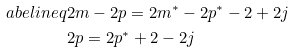Convert formula to latex. <formula><loc_0><loc_0><loc_500><loc_500>\L a b e l { i n e q } & 2 m - 2 p = 2 m ^ { * } - 2 p ^ { * } - 2 + 2 j \\ & 2 p = 2 p ^ { * } + 2 - 2 j</formula> 